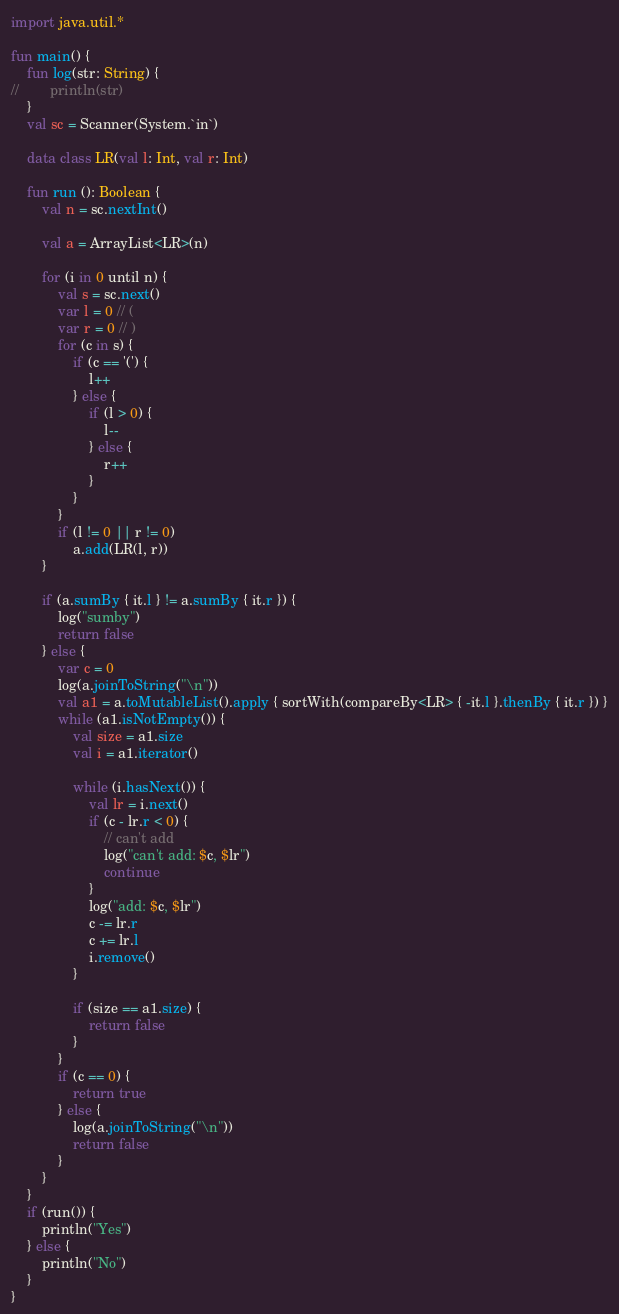<code> <loc_0><loc_0><loc_500><loc_500><_Kotlin_>import java.util.*

fun main() {
    fun log(str: String) {
//        println(str)
    }
    val sc = Scanner(System.`in`)

    data class LR(val l: Int, val r: Int)

    fun run (): Boolean {
        val n = sc.nextInt()

        val a = ArrayList<LR>(n)

        for (i in 0 until n) {
            val s = sc.next()
            var l = 0 // (
            var r = 0 // )
            for (c in s) {
                if (c == '(') {
                    l++
                } else {
                    if (l > 0) {
                        l--
                    } else {
                        r++
                    }
                }
            }
            if (l != 0 || r != 0)
                a.add(LR(l, r))
        }

        if (a.sumBy { it.l } != a.sumBy { it.r }) {
            log("sumby")
            return false
        } else {
            var c = 0
            log(a.joinToString("\n"))
            val a1 = a.toMutableList().apply { sortWith(compareBy<LR> { -it.l }.thenBy { it.r }) }
            while (a1.isNotEmpty()) {
                val size = a1.size
                val i = a1.iterator()

                while (i.hasNext()) {
                    val lr = i.next()
                    if (c - lr.r < 0) {
                        // can't add
                        log("can't add: $c, $lr")
                        continue
                    }
                    log("add: $c, $lr")
                    c -= lr.r
                    c += lr.l
                    i.remove()
                }

                if (size == a1.size) {
                    return false
                }
            }
            if (c == 0) {
                return true
            } else {
                log(a.joinToString("\n"))
                return false
            }
        }
    }
    if (run()) {
        println("Yes")
    } else {
        println("No")
    }
}
</code> 